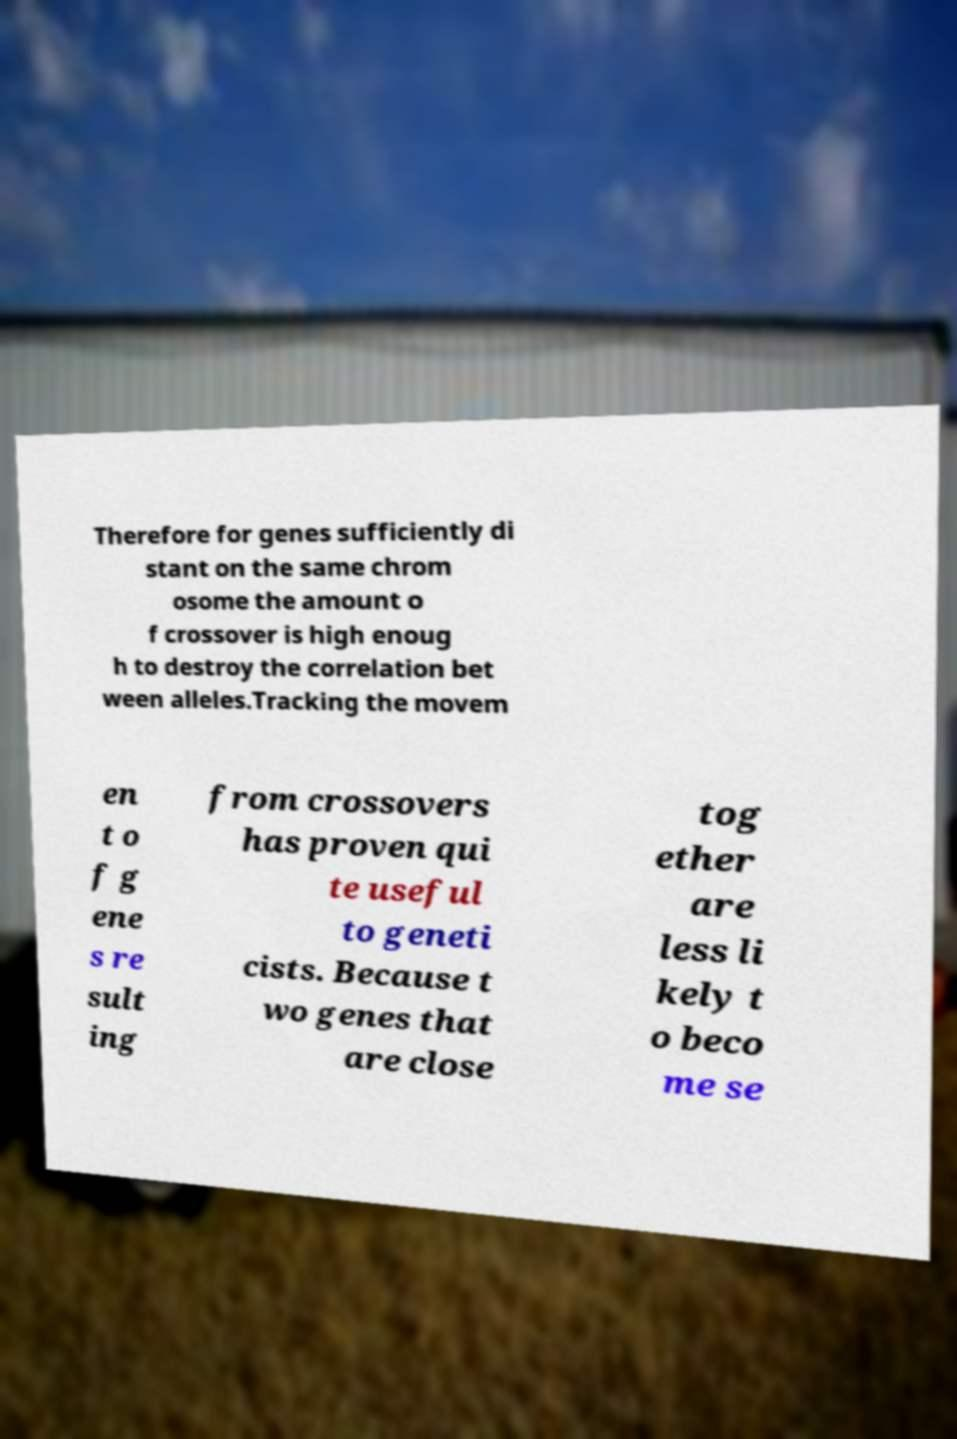What messages or text are displayed in this image? I need them in a readable, typed format. Therefore for genes sufficiently di stant on the same chrom osome the amount o f crossover is high enoug h to destroy the correlation bet ween alleles.Tracking the movem en t o f g ene s re sult ing from crossovers has proven qui te useful to geneti cists. Because t wo genes that are close tog ether are less li kely t o beco me se 